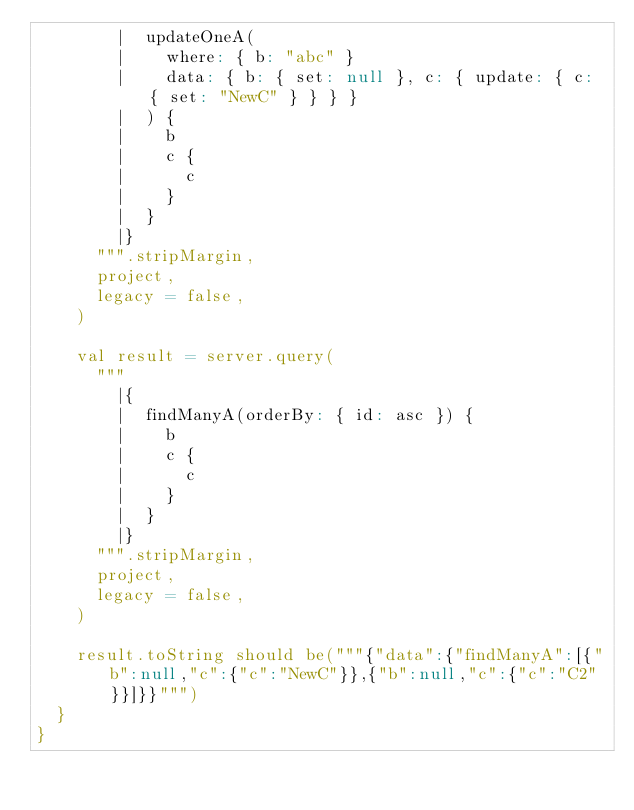Convert code to text. <code><loc_0><loc_0><loc_500><loc_500><_Scala_>        |  updateOneA(
        |    where: { b: "abc" }
        |    data: { b: { set: null }, c: { update: { c: { set: "NewC" } } } }
        |  ) {
        |    b
        |    c {
        |      c
        |    }
        |  }
        |}
      """.stripMargin,
      project,
      legacy = false,
    )

    val result = server.query(
      """
        |{
        |  findManyA(orderBy: { id: asc }) {
        |    b
        |    c {
        |      c
        |    }
        |  }
        |}
      """.stripMargin,
      project,
      legacy = false,
    )

    result.toString should be("""{"data":{"findManyA":[{"b":null,"c":{"c":"NewC"}},{"b":null,"c":{"c":"C2"}}]}}""")
  }
}
</code> 